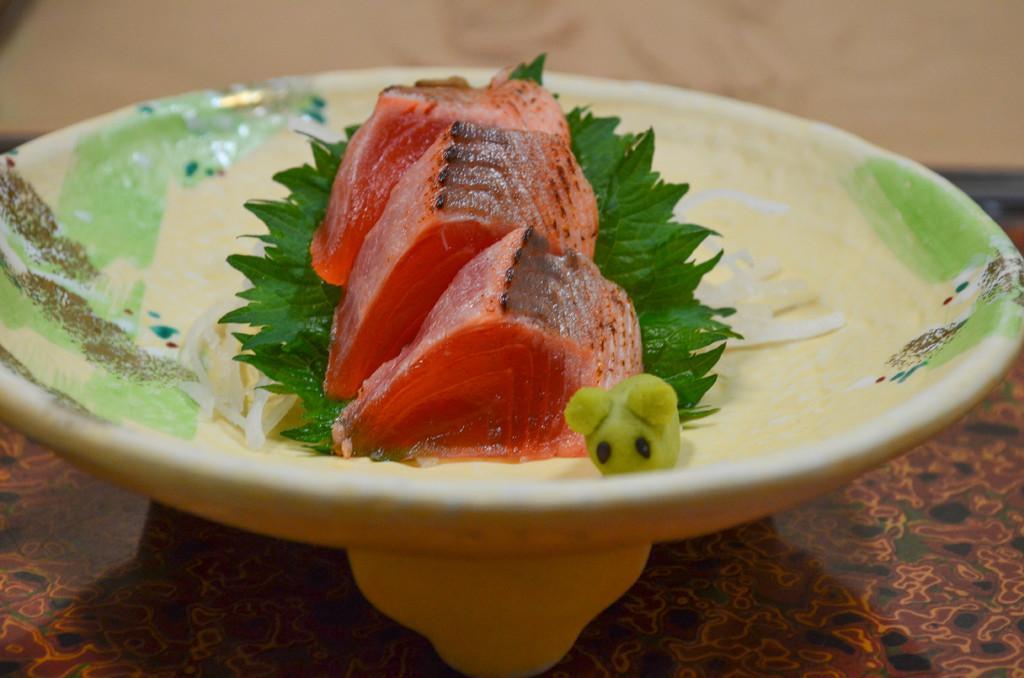Please provide a concise description of this image. In this image, we can see a food item on the plate, which is placed on the table. 